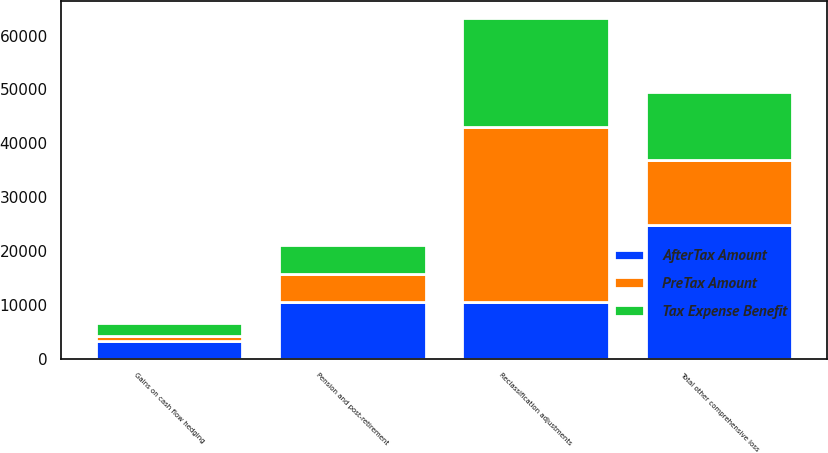Convert chart. <chart><loc_0><loc_0><loc_500><loc_500><stacked_bar_chart><ecel><fcel>Pension and post-retirement<fcel>Gains on cash flow hedging<fcel>Reclassification adjustments<fcel>Total other comprehensive loss<nl><fcel>AfterTax Amount<fcel>10529<fcel>3260<fcel>10529<fcel>24722<nl><fcel>Tax Expense Benefit<fcel>5399<fcel>2259<fcel>20157<fcel>12499<nl><fcel>PreTax Amount<fcel>5130<fcel>1001<fcel>32477<fcel>12223<nl></chart> 